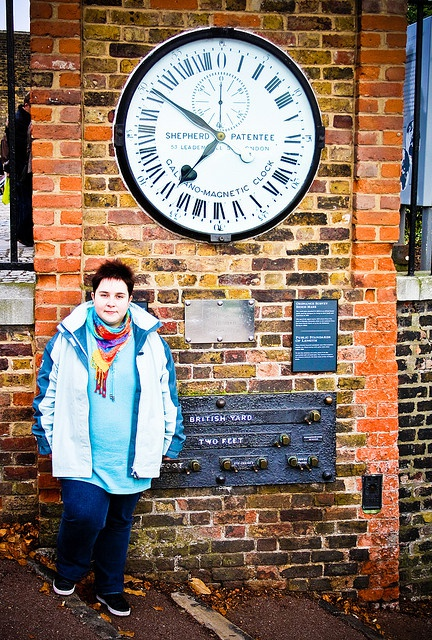Describe the objects in this image and their specific colors. I can see people in lavender, white, black, lightblue, and navy tones, clock in lavender, white, black, lightblue, and gray tones, and people in lavender, black, maroon, and brown tones in this image. 